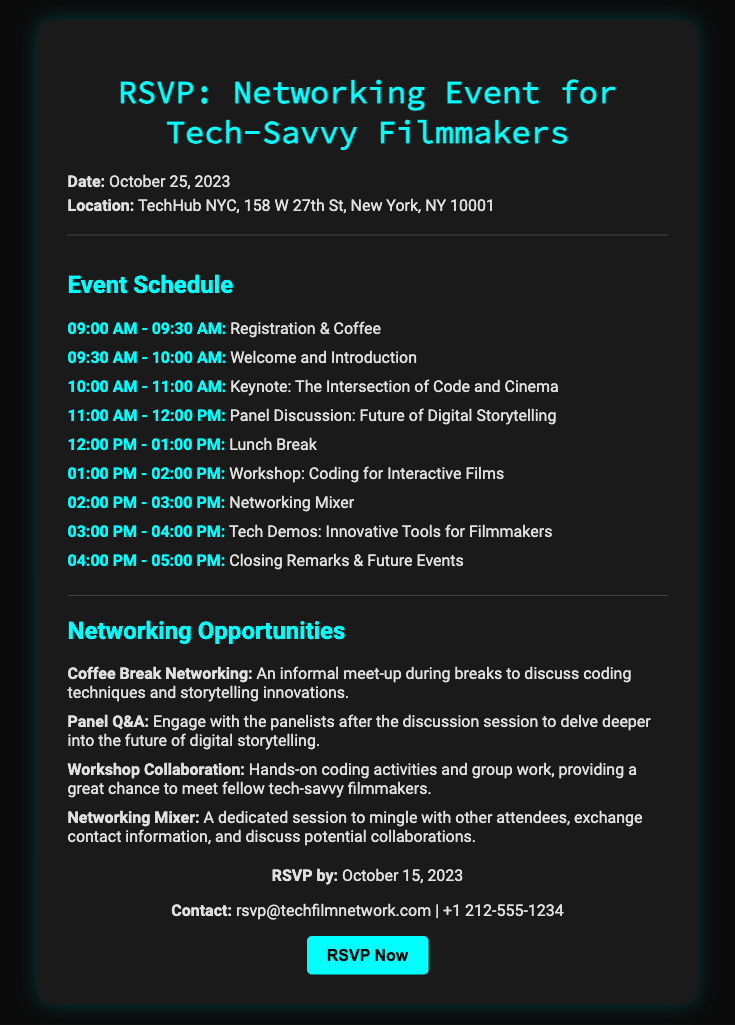What is the date of the event? The date is explicitly mentioned in the document as October 25, 2023.
Answer: October 25, 2023 Where is the event being held? The document provides the location of the event, which is TechHub NYC, 158 W 27th St, New York, NY 10001.
Answer: TechHub NYC, 158 W 27th St, New York, NY 10001 What is the time for registration? The schedule indicates that registration occurs from 09:00 AM to 09:30 AM.
Answer: 09:00 AM - 09:30 AM What is the title of the keynote session? The schedule lists the keynote session as "The Intersection of Code and Cinema."
Answer: The Intersection of Code and Cinema When is the RSVP deadline? The RSVP deadline is specified in the document as October 15, 2023.
Answer: October 15, 2023 Which networking opportunity allows informal discussion during breaks? The document mentions "Coffee Break Networking" as an informal meet-up during breaks.
Answer: Coffee Break Networking What activity occurs during the 01:00 PM to 02:00 PM slot? The schedule for that time slot is a "Workshop: Coding for Interactive Films."
Answer: Workshop: Coding for Interactive Films What is the contact email for RSVPs? The contact email for RSVPs is provided as rsvp@techfilmnetwork.com in the document.
Answer: rsvp@techfilmnetwork.com What is unique about the "Networking Mixer" session? The document states that it is a dedicated session to mingle with attendees and discuss potential collaborations.
Answer: Dedicated session to mingle and discuss collaborations 